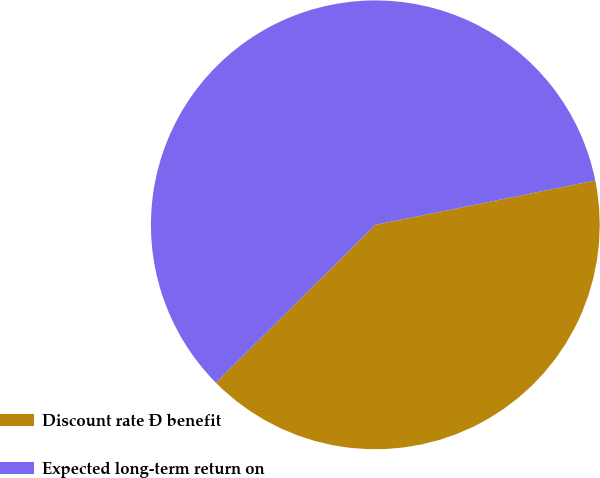Convert chart. <chart><loc_0><loc_0><loc_500><loc_500><pie_chart><fcel>Discount rate Ð benefit<fcel>Expected long-term return on<nl><fcel>40.74%<fcel>59.26%<nl></chart> 